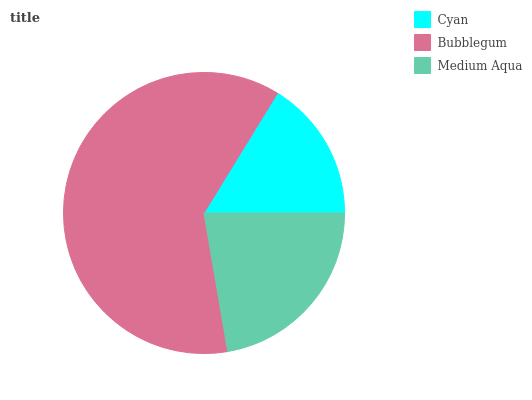Is Cyan the minimum?
Answer yes or no. Yes. Is Bubblegum the maximum?
Answer yes or no. Yes. Is Medium Aqua the minimum?
Answer yes or no. No. Is Medium Aqua the maximum?
Answer yes or no. No. Is Bubblegum greater than Medium Aqua?
Answer yes or no. Yes. Is Medium Aqua less than Bubblegum?
Answer yes or no. Yes. Is Medium Aqua greater than Bubblegum?
Answer yes or no. No. Is Bubblegum less than Medium Aqua?
Answer yes or no. No. Is Medium Aqua the high median?
Answer yes or no. Yes. Is Medium Aqua the low median?
Answer yes or no. Yes. Is Cyan the high median?
Answer yes or no. No. Is Cyan the low median?
Answer yes or no. No. 